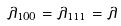<formula> <loc_0><loc_0><loc_500><loc_500>\lambda _ { 1 0 0 } = \lambda _ { 1 1 1 } = \lambda</formula> 